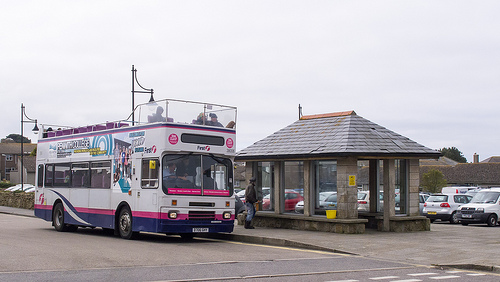Which kind of vehicle is to the left of the man? The vehicle to the left of the man is a bus. 